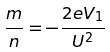Convert formula to latex. <formula><loc_0><loc_0><loc_500><loc_500>\frac { m } { n } = - \frac { 2 e V _ { 1 } } { U ^ { 2 } }</formula> 